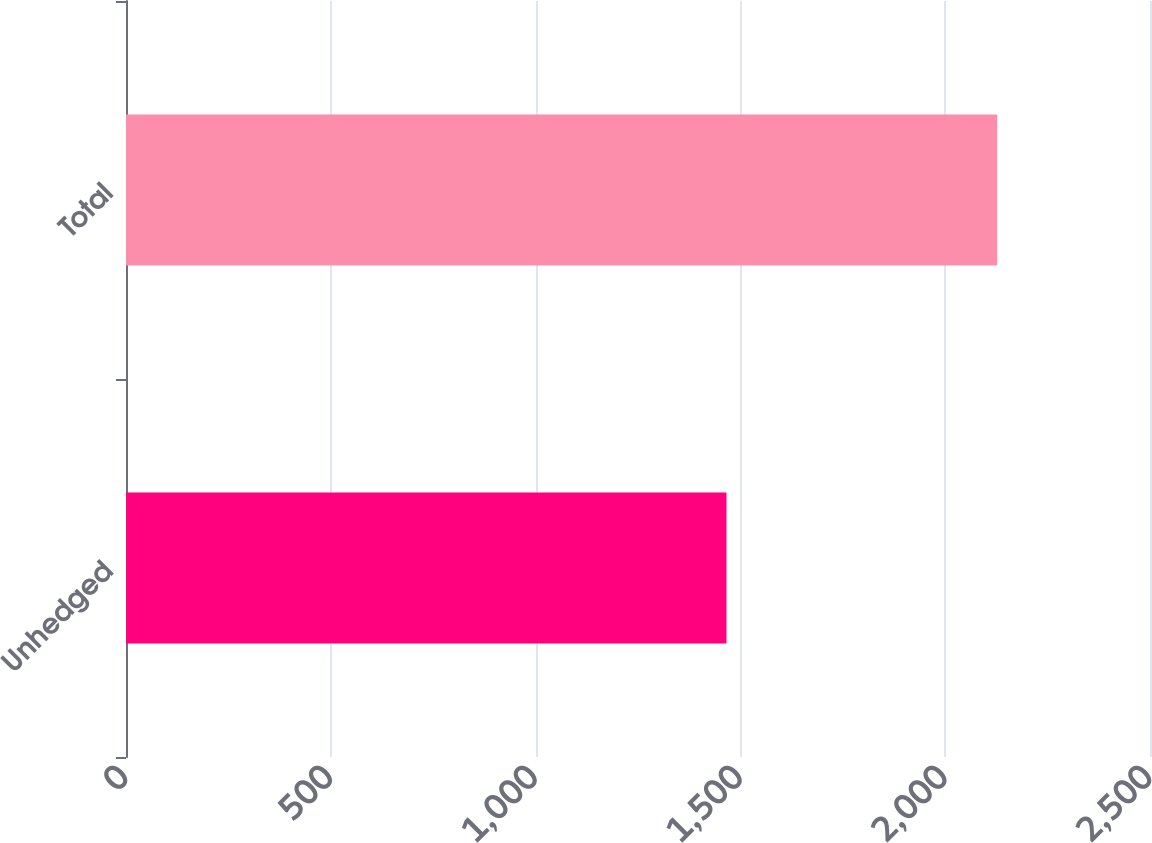Convert chart to OTSL. <chart><loc_0><loc_0><loc_500><loc_500><bar_chart><fcel>Unhedged<fcel>Total<nl><fcel>1466<fcel>2127<nl></chart> 